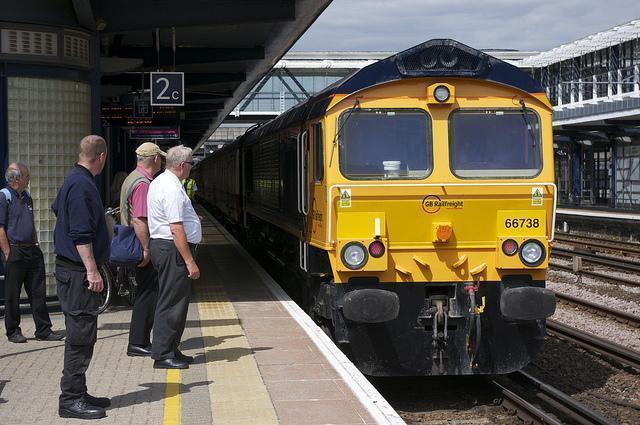Why is there a yellow line on the ground?
Choose the correct response and explain in the format: 'Answer: answer
Rationale: rationale.'
Options: As prank, optical illusion, decoration, safety. Answer: safety.
Rationale: Yellow is for caution. 